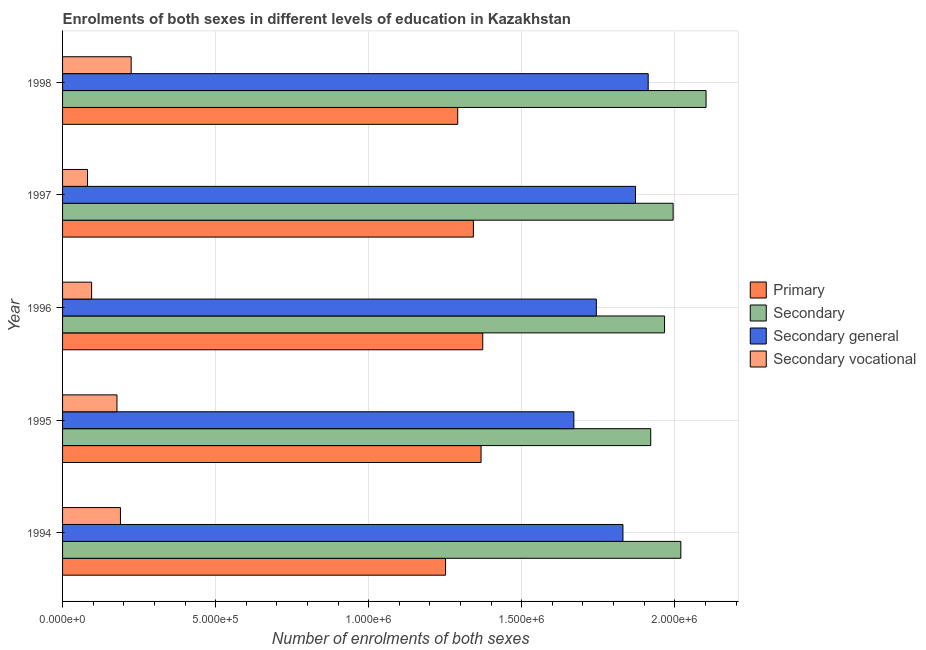How many different coloured bars are there?
Your answer should be compact. 4. How many groups of bars are there?
Your response must be concise. 5. Are the number of bars on each tick of the Y-axis equal?
Offer a terse response. Yes. How many bars are there on the 5th tick from the top?
Offer a very short reply. 4. How many bars are there on the 4th tick from the bottom?
Offer a terse response. 4. In how many cases, is the number of bars for a given year not equal to the number of legend labels?
Provide a succinct answer. 0. What is the number of enrolments in secondary general education in 1996?
Provide a short and direct response. 1.74e+06. Across all years, what is the maximum number of enrolments in secondary education?
Ensure brevity in your answer.  2.10e+06. Across all years, what is the minimum number of enrolments in secondary general education?
Your answer should be very brief. 1.67e+06. What is the total number of enrolments in secondary education in the graph?
Your response must be concise. 1.00e+07. What is the difference between the number of enrolments in secondary education in 1995 and that in 1997?
Ensure brevity in your answer.  -7.32e+04. What is the difference between the number of enrolments in secondary education in 1997 and the number of enrolments in primary education in 1995?
Provide a short and direct response. 6.27e+05. What is the average number of enrolments in primary education per year?
Offer a very short reply. 1.32e+06. In the year 1998, what is the difference between the number of enrolments in primary education and number of enrolments in secondary education?
Offer a terse response. -8.11e+05. In how many years, is the number of enrolments in primary education greater than 400000 ?
Your answer should be very brief. 5. Is the difference between the number of enrolments in secondary vocational education in 1997 and 1998 greater than the difference between the number of enrolments in primary education in 1997 and 1998?
Offer a very short reply. No. What is the difference between the highest and the second highest number of enrolments in secondary education?
Keep it short and to the point. 8.25e+04. What is the difference between the highest and the lowest number of enrolments in secondary general education?
Make the answer very short. 2.43e+05. What does the 1st bar from the top in 1996 represents?
Provide a succinct answer. Secondary vocational. What does the 4th bar from the bottom in 1994 represents?
Offer a very short reply. Secondary vocational. Are all the bars in the graph horizontal?
Your response must be concise. Yes. How many years are there in the graph?
Keep it short and to the point. 5. Does the graph contain grids?
Provide a short and direct response. Yes. Where does the legend appear in the graph?
Keep it short and to the point. Center right. How are the legend labels stacked?
Make the answer very short. Vertical. What is the title of the graph?
Give a very brief answer. Enrolments of both sexes in different levels of education in Kazakhstan. Does "Other expenses" appear as one of the legend labels in the graph?
Give a very brief answer. No. What is the label or title of the X-axis?
Offer a terse response. Number of enrolments of both sexes. What is the Number of enrolments of both sexes of Primary in 1994?
Offer a terse response. 1.25e+06. What is the Number of enrolments of both sexes in Secondary in 1994?
Your answer should be very brief. 2.02e+06. What is the Number of enrolments of both sexes in Secondary general in 1994?
Give a very brief answer. 1.83e+06. What is the Number of enrolments of both sexes of Secondary vocational in 1994?
Offer a very short reply. 1.89e+05. What is the Number of enrolments of both sexes of Primary in 1995?
Keep it short and to the point. 1.37e+06. What is the Number of enrolments of both sexes in Secondary in 1995?
Give a very brief answer. 1.92e+06. What is the Number of enrolments of both sexes in Secondary general in 1995?
Offer a terse response. 1.67e+06. What is the Number of enrolments of both sexes of Secondary vocational in 1995?
Make the answer very short. 1.78e+05. What is the Number of enrolments of both sexes in Primary in 1996?
Provide a succinct answer. 1.37e+06. What is the Number of enrolments of both sexes of Secondary in 1996?
Give a very brief answer. 1.97e+06. What is the Number of enrolments of both sexes of Secondary general in 1996?
Provide a succinct answer. 1.74e+06. What is the Number of enrolments of both sexes of Secondary vocational in 1996?
Your answer should be very brief. 9.49e+04. What is the Number of enrolments of both sexes of Primary in 1997?
Offer a very short reply. 1.34e+06. What is the Number of enrolments of both sexes of Secondary in 1997?
Your answer should be very brief. 1.99e+06. What is the Number of enrolments of both sexes in Secondary general in 1997?
Make the answer very short. 1.87e+06. What is the Number of enrolments of both sexes of Secondary vocational in 1997?
Provide a succinct answer. 8.15e+04. What is the Number of enrolments of both sexes in Primary in 1998?
Offer a very short reply. 1.29e+06. What is the Number of enrolments of both sexes in Secondary in 1998?
Offer a very short reply. 2.10e+06. What is the Number of enrolments of both sexes of Secondary general in 1998?
Keep it short and to the point. 1.91e+06. What is the Number of enrolments of both sexes of Secondary vocational in 1998?
Provide a short and direct response. 2.24e+05. Across all years, what is the maximum Number of enrolments of both sexes of Primary?
Ensure brevity in your answer.  1.37e+06. Across all years, what is the maximum Number of enrolments of both sexes of Secondary?
Your answer should be very brief. 2.10e+06. Across all years, what is the maximum Number of enrolments of both sexes of Secondary general?
Make the answer very short. 1.91e+06. Across all years, what is the maximum Number of enrolments of both sexes of Secondary vocational?
Provide a short and direct response. 2.24e+05. Across all years, what is the minimum Number of enrolments of both sexes in Primary?
Your answer should be compact. 1.25e+06. Across all years, what is the minimum Number of enrolments of both sexes in Secondary?
Keep it short and to the point. 1.92e+06. Across all years, what is the minimum Number of enrolments of both sexes in Secondary general?
Your answer should be very brief. 1.67e+06. Across all years, what is the minimum Number of enrolments of both sexes in Secondary vocational?
Keep it short and to the point. 8.15e+04. What is the total Number of enrolments of both sexes in Primary in the graph?
Provide a succinct answer. 6.62e+06. What is the total Number of enrolments of both sexes of Secondary in the graph?
Offer a terse response. 1.00e+07. What is the total Number of enrolments of both sexes of Secondary general in the graph?
Your answer should be compact. 9.03e+06. What is the total Number of enrolments of both sexes of Secondary vocational in the graph?
Keep it short and to the point. 7.67e+05. What is the difference between the Number of enrolments of both sexes of Primary in 1994 and that in 1995?
Ensure brevity in your answer.  -1.16e+05. What is the difference between the Number of enrolments of both sexes of Secondary in 1994 and that in 1995?
Offer a terse response. 9.84e+04. What is the difference between the Number of enrolments of both sexes in Secondary general in 1994 and that in 1995?
Your answer should be compact. 1.60e+05. What is the difference between the Number of enrolments of both sexes in Secondary vocational in 1994 and that in 1995?
Give a very brief answer. 1.14e+04. What is the difference between the Number of enrolments of both sexes in Primary in 1994 and that in 1996?
Make the answer very short. -1.21e+05. What is the difference between the Number of enrolments of both sexes of Secondary in 1994 and that in 1996?
Provide a succinct answer. 5.32e+04. What is the difference between the Number of enrolments of both sexes of Secondary general in 1994 and that in 1996?
Provide a short and direct response. 8.70e+04. What is the difference between the Number of enrolments of both sexes of Secondary vocational in 1994 and that in 1996?
Your response must be concise. 9.42e+04. What is the difference between the Number of enrolments of both sexes of Primary in 1994 and that in 1997?
Ensure brevity in your answer.  -9.09e+04. What is the difference between the Number of enrolments of both sexes in Secondary in 1994 and that in 1997?
Provide a succinct answer. 2.52e+04. What is the difference between the Number of enrolments of both sexes of Secondary general in 1994 and that in 1997?
Give a very brief answer. -4.10e+04. What is the difference between the Number of enrolments of both sexes of Secondary vocational in 1994 and that in 1997?
Keep it short and to the point. 1.08e+05. What is the difference between the Number of enrolments of both sexes in Primary in 1994 and that in 1998?
Your answer should be very brief. -3.97e+04. What is the difference between the Number of enrolments of both sexes of Secondary in 1994 and that in 1998?
Provide a succinct answer. -8.25e+04. What is the difference between the Number of enrolments of both sexes in Secondary general in 1994 and that in 1998?
Offer a terse response. -8.24e+04. What is the difference between the Number of enrolments of both sexes of Secondary vocational in 1994 and that in 1998?
Make the answer very short. -3.50e+04. What is the difference between the Number of enrolments of both sexes of Primary in 1995 and that in 1996?
Keep it short and to the point. -5534. What is the difference between the Number of enrolments of both sexes in Secondary in 1995 and that in 1996?
Provide a succinct answer. -4.52e+04. What is the difference between the Number of enrolments of both sexes of Secondary general in 1995 and that in 1996?
Offer a very short reply. -7.34e+04. What is the difference between the Number of enrolments of both sexes of Secondary vocational in 1995 and that in 1996?
Offer a terse response. 8.28e+04. What is the difference between the Number of enrolments of both sexes in Primary in 1995 and that in 1997?
Ensure brevity in your answer.  2.50e+04. What is the difference between the Number of enrolments of both sexes of Secondary in 1995 and that in 1997?
Your response must be concise. -7.32e+04. What is the difference between the Number of enrolments of both sexes in Secondary general in 1995 and that in 1997?
Offer a very short reply. -2.01e+05. What is the difference between the Number of enrolments of both sexes in Secondary vocational in 1995 and that in 1997?
Your answer should be very brief. 9.62e+04. What is the difference between the Number of enrolments of both sexes of Primary in 1995 and that in 1998?
Give a very brief answer. 7.63e+04. What is the difference between the Number of enrolments of both sexes of Secondary in 1995 and that in 1998?
Provide a succinct answer. -1.81e+05. What is the difference between the Number of enrolments of both sexes in Secondary general in 1995 and that in 1998?
Your answer should be compact. -2.43e+05. What is the difference between the Number of enrolments of both sexes in Secondary vocational in 1995 and that in 1998?
Make the answer very short. -4.65e+04. What is the difference between the Number of enrolments of both sexes in Primary in 1996 and that in 1997?
Offer a very short reply. 3.06e+04. What is the difference between the Number of enrolments of both sexes in Secondary in 1996 and that in 1997?
Your answer should be compact. -2.80e+04. What is the difference between the Number of enrolments of both sexes of Secondary general in 1996 and that in 1997?
Offer a very short reply. -1.28e+05. What is the difference between the Number of enrolments of both sexes in Secondary vocational in 1996 and that in 1997?
Offer a terse response. 1.34e+04. What is the difference between the Number of enrolments of both sexes in Primary in 1996 and that in 1998?
Offer a terse response. 8.18e+04. What is the difference between the Number of enrolments of both sexes in Secondary in 1996 and that in 1998?
Your answer should be very brief. -1.36e+05. What is the difference between the Number of enrolments of both sexes of Secondary general in 1996 and that in 1998?
Give a very brief answer. -1.69e+05. What is the difference between the Number of enrolments of both sexes of Secondary vocational in 1996 and that in 1998?
Offer a very short reply. -1.29e+05. What is the difference between the Number of enrolments of both sexes of Primary in 1997 and that in 1998?
Offer a terse response. 5.12e+04. What is the difference between the Number of enrolments of both sexes in Secondary in 1997 and that in 1998?
Your answer should be compact. -1.08e+05. What is the difference between the Number of enrolments of both sexes of Secondary general in 1997 and that in 1998?
Give a very brief answer. -4.14e+04. What is the difference between the Number of enrolments of both sexes in Secondary vocational in 1997 and that in 1998?
Provide a short and direct response. -1.43e+05. What is the difference between the Number of enrolments of both sexes of Primary in 1994 and the Number of enrolments of both sexes of Secondary in 1995?
Provide a succinct answer. -6.70e+05. What is the difference between the Number of enrolments of both sexes of Primary in 1994 and the Number of enrolments of both sexes of Secondary general in 1995?
Provide a succinct answer. -4.19e+05. What is the difference between the Number of enrolments of both sexes of Primary in 1994 and the Number of enrolments of both sexes of Secondary vocational in 1995?
Keep it short and to the point. 1.07e+06. What is the difference between the Number of enrolments of both sexes in Secondary in 1994 and the Number of enrolments of both sexes in Secondary general in 1995?
Your answer should be compact. 3.50e+05. What is the difference between the Number of enrolments of both sexes of Secondary in 1994 and the Number of enrolments of both sexes of Secondary vocational in 1995?
Provide a succinct answer. 1.84e+06. What is the difference between the Number of enrolments of both sexes in Secondary general in 1994 and the Number of enrolments of both sexes in Secondary vocational in 1995?
Make the answer very short. 1.65e+06. What is the difference between the Number of enrolments of both sexes of Primary in 1994 and the Number of enrolments of both sexes of Secondary in 1996?
Give a very brief answer. -7.15e+05. What is the difference between the Number of enrolments of both sexes in Primary in 1994 and the Number of enrolments of both sexes in Secondary general in 1996?
Ensure brevity in your answer.  -4.93e+05. What is the difference between the Number of enrolments of both sexes of Primary in 1994 and the Number of enrolments of both sexes of Secondary vocational in 1996?
Offer a terse response. 1.16e+06. What is the difference between the Number of enrolments of both sexes of Secondary in 1994 and the Number of enrolments of both sexes of Secondary general in 1996?
Make the answer very short. 2.76e+05. What is the difference between the Number of enrolments of both sexes in Secondary in 1994 and the Number of enrolments of both sexes in Secondary vocational in 1996?
Your answer should be compact. 1.92e+06. What is the difference between the Number of enrolments of both sexes in Secondary general in 1994 and the Number of enrolments of both sexes in Secondary vocational in 1996?
Give a very brief answer. 1.74e+06. What is the difference between the Number of enrolments of both sexes of Primary in 1994 and the Number of enrolments of both sexes of Secondary in 1997?
Your answer should be compact. -7.43e+05. What is the difference between the Number of enrolments of both sexes of Primary in 1994 and the Number of enrolments of both sexes of Secondary general in 1997?
Provide a short and direct response. -6.20e+05. What is the difference between the Number of enrolments of both sexes of Primary in 1994 and the Number of enrolments of both sexes of Secondary vocational in 1997?
Provide a succinct answer. 1.17e+06. What is the difference between the Number of enrolments of both sexes in Secondary in 1994 and the Number of enrolments of both sexes in Secondary general in 1997?
Your answer should be compact. 1.48e+05. What is the difference between the Number of enrolments of both sexes in Secondary in 1994 and the Number of enrolments of both sexes in Secondary vocational in 1997?
Provide a short and direct response. 1.94e+06. What is the difference between the Number of enrolments of both sexes of Secondary general in 1994 and the Number of enrolments of both sexes of Secondary vocational in 1997?
Provide a succinct answer. 1.75e+06. What is the difference between the Number of enrolments of both sexes of Primary in 1994 and the Number of enrolments of both sexes of Secondary in 1998?
Your answer should be compact. -8.51e+05. What is the difference between the Number of enrolments of both sexes of Primary in 1994 and the Number of enrolments of both sexes of Secondary general in 1998?
Give a very brief answer. -6.62e+05. What is the difference between the Number of enrolments of both sexes in Primary in 1994 and the Number of enrolments of both sexes in Secondary vocational in 1998?
Keep it short and to the point. 1.03e+06. What is the difference between the Number of enrolments of both sexes of Secondary in 1994 and the Number of enrolments of both sexes of Secondary general in 1998?
Your answer should be very brief. 1.07e+05. What is the difference between the Number of enrolments of both sexes of Secondary in 1994 and the Number of enrolments of both sexes of Secondary vocational in 1998?
Offer a very short reply. 1.80e+06. What is the difference between the Number of enrolments of both sexes of Secondary general in 1994 and the Number of enrolments of both sexes of Secondary vocational in 1998?
Offer a terse response. 1.61e+06. What is the difference between the Number of enrolments of both sexes in Primary in 1995 and the Number of enrolments of both sexes in Secondary in 1996?
Your answer should be compact. -5.99e+05. What is the difference between the Number of enrolments of both sexes in Primary in 1995 and the Number of enrolments of both sexes in Secondary general in 1996?
Your answer should be compact. -3.77e+05. What is the difference between the Number of enrolments of both sexes of Primary in 1995 and the Number of enrolments of both sexes of Secondary vocational in 1996?
Your answer should be compact. 1.27e+06. What is the difference between the Number of enrolments of both sexes in Secondary in 1995 and the Number of enrolments of both sexes in Secondary general in 1996?
Provide a succinct answer. 1.78e+05. What is the difference between the Number of enrolments of both sexes in Secondary in 1995 and the Number of enrolments of both sexes in Secondary vocational in 1996?
Your answer should be compact. 1.83e+06. What is the difference between the Number of enrolments of both sexes of Secondary general in 1995 and the Number of enrolments of both sexes of Secondary vocational in 1996?
Offer a terse response. 1.58e+06. What is the difference between the Number of enrolments of both sexes of Primary in 1995 and the Number of enrolments of both sexes of Secondary in 1997?
Your answer should be very brief. -6.27e+05. What is the difference between the Number of enrolments of both sexes of Primary in 1995 and the Number of enrolments of both sexes of Secondary general in 1997?
Your answer should be compact. -5.05e+05. What is the difference between the Number of enrolments of both sexes of Primary in 1995 and the Number of enrolments of both sexes of Secondary vocational in 1997?
Keep it short and to the point. 1.29e+06. What is the difference between the Number of enrolments of both sexes in Secondary in 1995 and the Number of enrolments of both sexes in Secondary general in 1997?
Your answer should be very brief. 4.97e+04. What is the difference between the Number of enrolments of both sexes of Secondary in 1995 and the Number of enrolments of both sexes of Secondary vocational in 1997?
Ensure brevity in your answer.  1.84e+06. What is the difference between the Number of enrolments of both sexes in Secondary general in 1995 and the Number of enrolments of both sexes in Secondary vocational in 1997?
Your answer should be very brief. 1.59e+06. What is the difference between the Number of enrolments of both sexes in Primary in 1995 and the Number of enrolments of both sexes in Secondary in 1998?
Provide a short and direct response. -7.35e+05. What is the difference between the Number of enrolments of both sexes in Primary in 1995 and the Number of enrolments of both sexes in Secondary general in 1998?
Your response must be concise. -5.46e+05. What is the difference between the Number of enrolments of both sexes of Primary in 1995 and the Number of enrolments of both sexes of Secondary vocational in 1998?
Provide a succinct answer. 1.14e+06. What is the difference between the Number of enrolments of both sexes of Secondary in 1995 and the Number of enrolments of both sexes of Secondary general in 1998?
Keep it short and to the point. 8285. What is the difference between the Number of enrolments of both sexes of Secondary in 1995 and the Number of enrolments of both sexes of Secondary vocational in 1998?
Give a very brief answer. 1.70e+06. What is the difference between the Number of enrolments of both sexes of Secondary general in 1995 and the Number of enrolments of both sexes of Secondary vocational in 1998?
Provide a short and direct response. 1.45e+06. What is the difference between the Number of enrolments of both sexes of Primary in 1996 and the Number of enrolments of both sexes of Secondary in 1997?
Your answer should be very brief. -6.22e+05. What is the difference between the Number of enrolments of both sexes in Primary in 1996 and the Number of enrolments of both sexes in Secondary general in 1997?
Make the answer very short. -4.99e+05. What is the difference between the Number of enrolments of both sexes in Primary in 1996 and the Number of enrolments of both sexes in Secondary vocational in 1997?
Your answer should be very brief. 1.29e+06. What is the difference between the Number of enrolments of both sexes in Secondary in 1996 and the Number of enrolments of both sexes in Secondary general in 1997?
Your answer should be compact. 9.49e+04. What is the difference between the Number of enrolments of both sexes of Secondary in 1996 and the Number of enrolments of both sexes of Secondary vocational in 1997?
Provide a succinct answer. 1.88e+06. What is the difference between the Number of enrolments of both sexes of Secondary general in 1996 and the Number of enrolments of both sexes of Secondary vocational in 1997?
Keep it short and to the point. 1.66e+06. What is the difference between the Number of enrolments of both sexes in Primary in 1996 and the Number of enrolments of both sexes in Secondary in 1998?
Ensure brevity in your answer.  -7.30e+05. What is the difference between the Number of enrolments of both sexes of Primary in 1996 and the Number of enrolments of both sexes of Secondary general in 1998?
Ensure brevity in your answer.  -5.40e+05. What is the difference between the Number of enrolments of both sexes in Primary in 1996 and the Number of enrolments of both sexes in Secondary vocational in 1998?
Your response must be concise. 1.15e+06. What is the difference between the Number of enrolments of both sexes of Secondary in 1996 and the Number of enrolments of both sexes of Secondary general in 1998?
Offer a very short reply. 5.35e+04. What is the difference between the Number of enrolments of both sexes of Secondary in 1996 and the Number of enrolments of both sexes of Secondary vocational in 1998?
Your answer should be compact. 1.74e+06. What is the difference between the Number of enrolments of both sexes of Secondary general in 1996 and the Number of enrolments of both sexes of Secondary vocational in 1998?
Ensure brevity in your answer.  1.52e+06. What is the difference between the Number of enrolments of both sexes of Primary in 1997 and the Number of enrolments of both sexes of Secondary in 1998?
Ensure brevity in your answer.  -7.60e+05. What is the difference between the Number of enrolments of both sexes of Primary in 1997 and the Number of enrolments of both sexes of Secondary general in 1998?
Provide a succinct answer. -5.71e+05. What is the difference between the Number of enrolments of both sexes in Primary in 1997 and the Number of enrolments of both sexes in Secondary vocational in 1998?
Offer a very short reply. 1.12e+06. What is the difference between the Number of enrolments of both sexes in Secondary in 1997 and the Number of enrolments of both sexes in Secondary general in 1998?
Your answer should be compact. 8.15e+04. What is the difference between the Number of enrolments of both sexes in Secondary in 1997 and the Number of enrolments of both sexes in Secondary vocational in 1998?
Offer a very short reply. 1.77e+06. What is the difference between the Number of enrolments of both sexes of Secondary general in 1997 and the Number of enrolments of both sexes of Secondary vocational in 1998?
Provide a short and direct response. 1.65e+06. What is the average Number of enrolments of both sexes of Primary per year?
Offer a very short reply. 1.32e+06. What is the average Number of enrolments of both sexes in Secondary per year?
Provide a succinct answer. 2.00e+06. What is the average Number of enrolments of both sexes of Secondary general per year?
Offer a very short reply. 1.81e+06. What is the average Number of enrolments of both sexes of Secondary vocational per year?
Your answer should be very brief. 1.53e+05. In the year 1994, what is the difference between the Number of enrolments of both sexes of Primary and Number of enrolments of both sexes of Secondary?
Your response must be concise. -7.69e+05. In the year 1994, what is the difference between the Number of enrolments of both sexes of Primary and Number of enrolments of both sexes of Secondary general?
Offer a terse response. -5.79e+05. In the year 1994, what is the difference between the Number of enrolments of both sexes of Primary and Number of enrolments of both sexes of Secondary vocational?
Keep it short and to the point. 1.06e+06. In the year 1994, what is the difference between the Number of enrolments of both sexes of Secondary and Number of enrolments of both sexes of Secondary general?
Make the answer very short. 1.89e+05. In the year 1994, what is the difference between the Number of enrolments of both sexes in Secondary and Number of enrolments of both sexes in Secondary vocational?
Give a very brief answer. 1.83e+06. In the year 1994, what is the difference between the Number of enrolments of both sexes of Secondary general and Number of enrolments of both sexes of Secondary vocational?
Give a very brief answer. 1.64e+06. In the year 1995, what is the difference between the Number of enrolments of both sexes in Primary and Number of enrolments of both sexes in Secondary?
Offer a terse response. -5.54e+05. In the year 1995, what is the difference between the Number of enrolments of both sexes in Primary and Number of enrolments of both sexes in Secondary general?
Your response must be concise. -3.03e+05. In the year 1995, what is the difference between the Number of enrolments of both sexes of Primary and Number of enrolments of both sexes of Secondary vocational?
Keep it short and to the point. 1.19e+06. In the year 1995, what is the difference between the Number of enrolments of both sexes of Secondary and Number of enrolments of both sexes of Secondary general?
Offer a very short reply. 2.51e+05. In the year 1995, what is the difference between the Number of enrolments of both sexes of Secondary and Number of enrolments of both sexes of Secondary vocational?
Your answer should be compact. 1.74e+06. In the year 1995, what is the difference between the Number of enrolments of both sexes of Secondary general and Number of enrolments of both sexes of Secondary vocational?
Your answer should be very brief. 1.49e+06. In the year 1996, what is the difference between the Number of enrolments of both sexes of Primary and Number of enrolments of both sexes of Secondary?
Your answer should be very brief. -5.94e+05. In the year 1996, what is the difference between the Number of enrolments of both sexes of Primary and Number of enrolments of both sexes of Secondary general?
Ensure brevity in your answer.  -3.71e+05. In the year 1996, what is the difference between the Number of enrolments of both sexes in Primary and Number of enrolments of both sexes in Secondary vocational?
Offer a terse response. 1.28e+06. In the year 1996, what is the difference between the Number of enrolments of both sexes of Secondary and Number of enrolments of both sexes of Secondary general?
Offer a terse response. 2.23e+05. In the year 1996, what is the difference between the Number of enrolments of both sexes in Secondary and Number of enrolments of both sexes in Secondary vocational?
Provide a succinct answer. 1.87e+06. In the year 1996, what is the difference between the Number of enrolments of both sexes of Secondary general and Number of enrolments of both sexes of Secondary vocational?
Offer a terse response. 1.65e+06. In the year 1997, what is the difference between the Number of enrolments of both sexes of Primary and Number of enrolments of both sexes of Secondary?
Your answer should be compact. -6.52e+05. In the year 1997, what is the difference between the Number of enrolments of both sexes of Primary and Number of enrolments of both sexes of Secondary general?
Your answer should be very brief. -5.30e+05. In the year 1997, what is the difference between the Number of enrolments of both sexes of Primary and Number of enrolments of both sexes of Secondary vocational?
Your answer should be very brief. 1.26e+06. In the year 1997, what is the difference between the Number of enrolments of both sexes of Secondary and Number of enrolments of both sexes of Secondary general?
Give a very brief answer. 1.23e+05. In the year 1997, what is the difference between the Number of enrolments of both sexes in Secondary and Number of enrolments of both sexes in Secondary vocational?
Offer a terse response. 1.91e+06. In the year 1997, what is the difference between the Number of enrolments of both sexes of Secondary general and Number of enrolments of both sexes of Secondary vocational?
Ensure brevity in your answer.  1.79e+06. In the year 1998, what is the difference between the Number of enrolments of both sexes of Primary and Number of enrolments of both sexes of Secondary?
Your response must be concise. -8.11e+05. In the year 1998, what is the difference between the Number of enrolments of both sexes of Primary and Number of enrolments of both sexes of Secondary general?
Your answer should be compact. -6.22e+05. In the year 1998, what is the difference between the Number of enrolments of both sexes of Primary and Number of enrolments of both sexes of Secondary vocational?
Give a very brief answer. 1.07e+06. In the year 1998, what is the difference between the Number of enrolments of both sexes of Secondary and Number of enrolments of both sexes of Secondary general?
Offer a terse response. 1.89e+05. In the year 1998, what is the difference between the Number of enrolments of both sexes in Secondary and Number of enrolments of both sexes in Secondary vocational?
Offer a terse response. 1.88e+06. In the year 1998, what is the difference between the Number of enrolments of both sexes in Secondary general and Number of enrolments of both sexes in Secondary vocational?
Your answer should be very brief. 1.69e+06. What is the ratio of the Number of enrolments of both sexes in Primary in 1994 to that in 1995?
Offer a very short reply. 0.92. What is the ratio of the Number of enrolments of both sexes of Secondary in 1994 to that in 1995?
Provide a short and direct response. 1.05. What is the ratio of the Number of enrolments of both sexes in Secondary general in 1994 to that in 1995?
Give a very brief answer. 1.1. What is the ratio of the Number of enrolments of both sexes in Secondary vocational in 1994 to that in 1995?
Provide a short and direct response. 1.06. What is the ratio of the Number of enrolments of both sexes of Primary in 1994 to that in 1996?
Offer a very short reply. 0.91. What is the ratio of the Number of enrolments of both sexes of Secondary in 1994 to that in 1996?
Provide a short and direct response. 1.03. What is the ratio of the Number of enrolments of both sexes of Secondary general in 1994 to that in 1996?
Your answer should be compact. 1.05. What is the ratio of the Number of enrolments of both sexes of Secondary vocational in 1994 to that in 1996?
Provide a succinct answer. 1.99. What is the ratio of the Number of enrolments of both sexes of Primary in 1994 to that in 1997?
Provide a short and direct response. 0.93. What is the ratio of the Number of enrolments of both sexes of Secondary in 1994 to that in 1997?
Keep it short and to the point. 1.01. What is the ratio of the Number of enrolments of both sexes in Secondary general in 1994 to that in 1997?
Offer a terse response. 0.98. What is the ratio of the Number of enrolments of both sexes in Secondary vocational in 1994 to that in 1997?
Provide a short and direct response. 2.32. What is the ratio of the Number of enrolments of both sexes in Primary in 1994 to that in 1998?
Keep it short and to the point. 0.97. What is the ratio of the Number of enrolments of both sexes of Secondary in 1994 to that in 1998?
Offer a terse response. 0.96. What is the ratio of the Number of enrolments of both sexes of Secondary general in 1994 to that in 1998?
Offer a very short reply. 0.96. What is the ratio of the Number of enrolments of both sexes of Secondary vocational in 1994 to that in 1998?
Provide a succinct answer. 0.84. What is the ratio of the Number of enrolments of both sexes of Secondary general in 1995 to that in 1996?
Offer a terse response. 0.96. What is the ratio of the Number of enrolments of both sexes in Secondary vocational in 1995 to that in 1996?
Offer a very short reply. 1.87. What is the ratio of the Number of enrolments of both sexes in Primary in 1995 to that in 1997?
Your answer should be compact. 1.02. What is the ratio of the Number of enrolments of both sexes of Secondary in 1995 to that in 1997?
Give a very brief answer. 0.96. What is the ratio of the Number of enrolments of both sexes in Secondary general in 1995 to that in 1997?
Offer a terse response. 0.89. What is the ratio of the Number of enrolments of both sexes in Secondary vocational in 1995 to that in 1997?
Offer a very short reply. 2.18. What is the ratio of the Number of enrolments of both sexes of Primary in 1995 to that in 1998?
Your response must be concise. 1.06. What is the ratio of the Number of enrolments of both sexes in Secondary in 1995 to that in 1998?
Offer a very short reply. 0.91. What is the ratio of the Number of enrolments of both sexes in Secondary general in 1995 to that in 1998?
Your answer should be very brief. 0.87. What is the ratio of the Number of enrolments of both sexes of Secondary vocational in 1995 to that in 1998?
Keep it short and to the point. 0.79. What is the ratio of the Number of enrolments of both sexes of Primary in 1996 to that in 1997?
Make the answer very short. 1.02. What is the ratio of the Number of enrolments of both sexes in Secondary in 1996 to that in 1997?
Keep it short and to the point. 0.99. What is the ratio of the Number of enrolments of both sexes of Secondary general in 1996 to that in 1997?
Offer a terse response. 0.93. What is the ratio of the Number of enrolments of both sexes of Secondary vocational in 1996 to that in 1997?
Ensure brevity in your answer.  1.16. What is the ratio of the Number of enrolments of both sexes in Primary in 1996 to that in 1998?
Your answer should be compact. 1.06. What is the ratio of the Number of enrolments of both sexes of Secondary in 1996 to that in 1998?
Give a very brief answer. 0.94. What is the ratio of the Number of enrolments of both sexes in Secondary general in 1996 to that in 1998?
Offer a very short reply. 0.91. What is the ratio of the Number of enrolments of both sexes in Secondary vocational in 1996 to that in 1998?
Offer a very short reply. 0.42. What is the ratio of the Number of enrolments of both sexes in Primary in 1997 to that in 1998?
Offer a very short reply. 1.04. What is the ratio of the Number of enrolments of both sexes of Secondary in 1997 to that in 1998?
Keep it short and to the point. 0.95. What is the ratio of the Number of enrolments of both sexes of Secondary general in 1997 to that in 1998?
Provide a succinct answer. 0.98. What is the ratio of the Number of enrolments of both sexes in Secondary vocational in 1997 to that in 1998?
Your answer should be compact. 0.36. What is the difference between the highest and the second highest Number of enrolments of both sexes in Primary?
Your response must be concise. 5534. What is the difference between the highest and the second highest Number of enrolments of both sexes in Secondary?
Make the answer very short. 8.25e+04. What is the difference between the highest and the second highest Number of enrolments of both sexes in Secondary general?
Ensure brevity in your answer.  4.14e+04. What is the difference between the highest and the second highest Number of enrolments of both sexes of Secondary vocational?
Ensure brevity in your answer.  3.50e+04. What is the difference between the highest and the lowest Number of enrolments of both sexes in Primary?
Provide a short and direct response. 1.21e+05. What is the difference between the highest and the lowest Number of enrolments of both sexes of Secondary?
Offer a terse response. 1.81e+05. What is the difference between the highest and the lowest Number of enrolments of both sexes of Secondary general?
Keep it short and to the point. 2.43e+05. What is the difference between the highest and the lowest Number of enrolments of both sexes in Secondary vocational?
Your answer should be compact. 1.43e+05. 